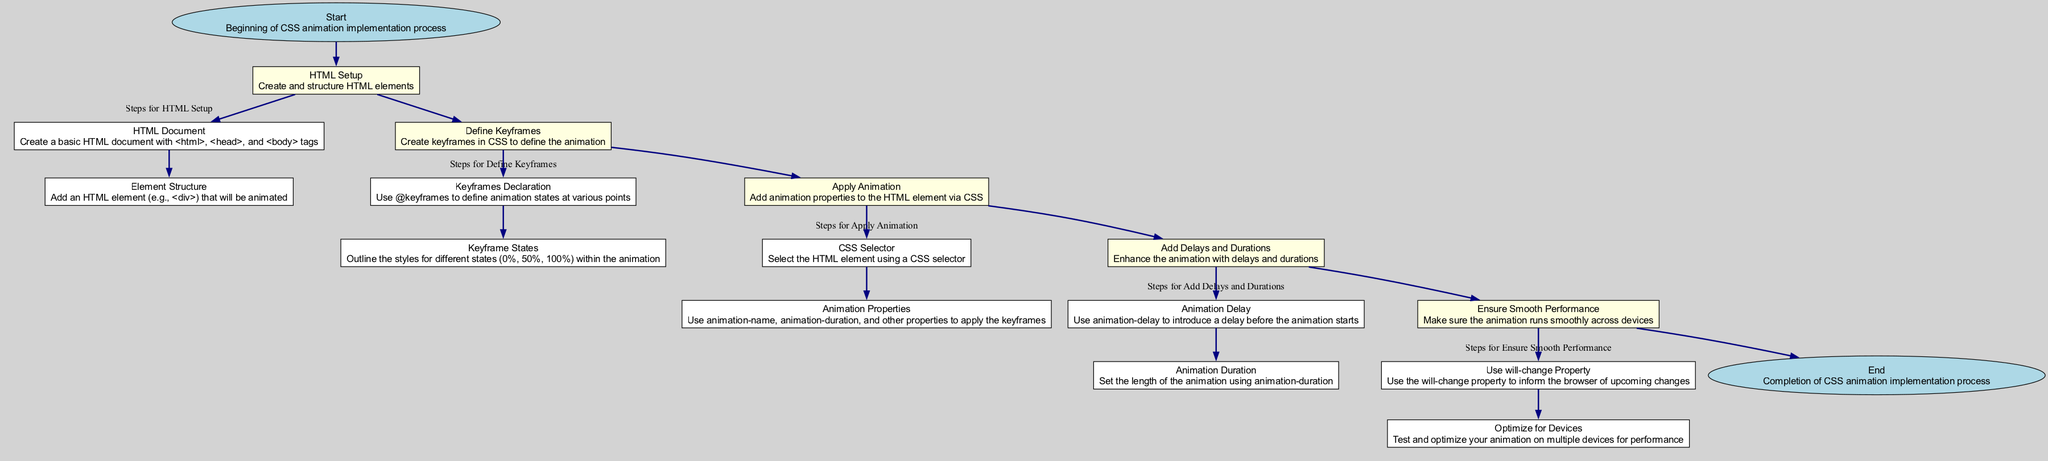What is the first stage in the diagram? The first stage is "Start," which is the initial point of the CSS animation implementation process.
Answer: Start How many main stages are there in the diagram? The diagram has six main stages, starting from "Start" and ending with "End."
Answer: Six What is the last step listed under the "Ensure Smooth Performance" stage? The last step under this stage is "Optimize for Devices," which focuses on testing and improving the animation on various devices.
Answer: Optimize for Devices Which stage contains the step "Keyframes Declaration"? "Keyframes Declaration" is located in the "Define Keyframes" stage, as it pertains to defining the animation keyframes in CSS.
Answer: Define Keyframes How many steps are there in the "Apply Animation" stage? There are two steps in the "Apply Animation" stage: "CSS Selector" and "Animation Properties."
Answer: Two In which stage would you introduce an animation delay? You would introduce an animation delay in the "Add Delays and Durations" stage, specifically using the "Animation Delay" step.
Answer: Add Delays and Durations What connects the "End" stage back to the previous stage? The "End" stage connects back to the "Ensure Smooth Performance" stage, indicating the final step following performance verification.
Answer: Ensure Smooth Performance What property is suggested for ensuring smooth performance in animations? The suggested property for ensuring smooth performance is "will-change," which informs the browser about possible upcoming changes.
Answer: will-change What type of element is suggested to be added in the HTML Setup stage? The element suggested to be added is a "div," which is a common choice for animation in web development.
Answer: div 